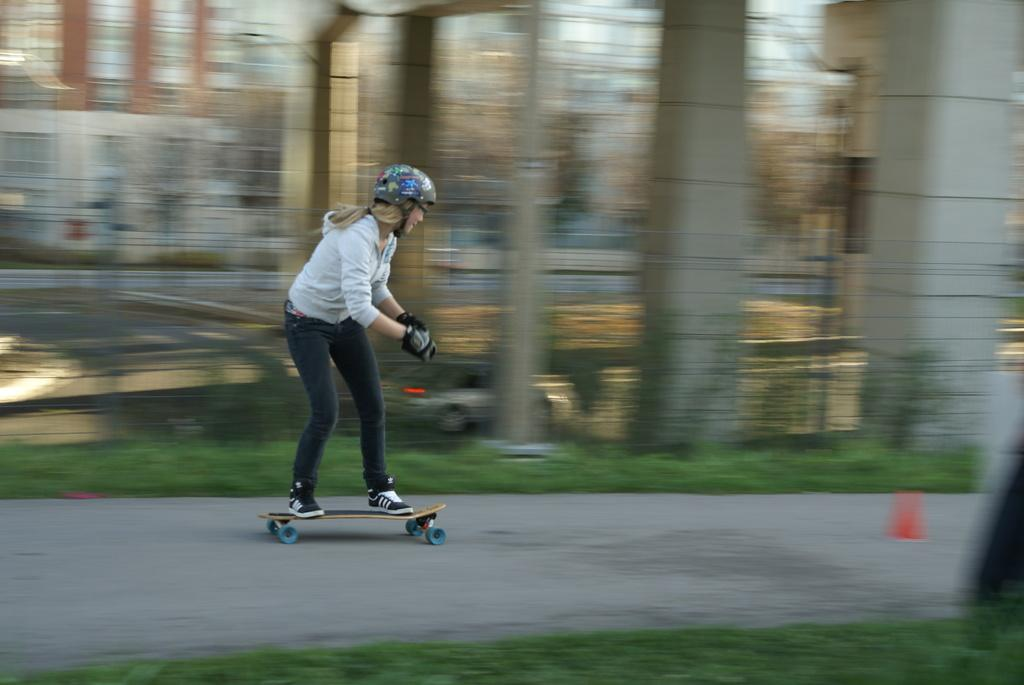Who is the main subject in the image? There is a woman in the image. What is the woman wearing on her upper body? The woman is wearing a white shirt. What is the woman wearing on her lower body? The woman is wearing black jeans. What is the woman wearing on her head? The woman is wearing a black helmet on her head. What activity is the woman engaged in? The woman is skating on the road. How would you describe the background of the image? The background of the image is blurred. What type of roof can be seen on the building in the image? There is no building or roof visible in the image; it features a woman skating on the road with a blurred background. 